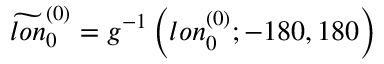<formula> <loc_0><loc_0><loc_500><loc_500>\widetilde { l o n } _ { 0 } ^ { ( 0 ) } = g ^ { - 1 } \left ( l o n _ { 0 } ^ { ( 0 ) } ; - 1 8 0 , 1 8 0 \right )</formula> 